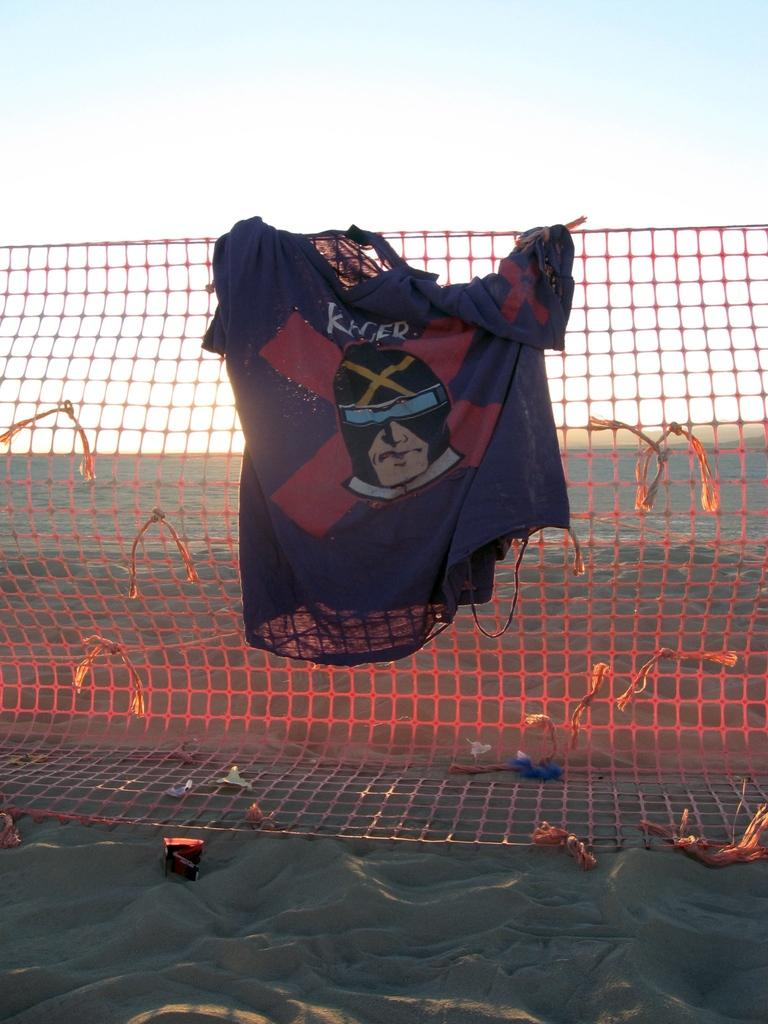What color is the cloth in the image? The cloth in the image is black. What is the black cloth placed on? The black cloth is on an orange net. What can be seen in the image besides the black cloth and orange net? There are objects visible in the image. What type of terrain is present in the image? There is sand in the image. What colors are visible in the sky in the image? The sky is white and blue in color. What type of teeth can be seen in the image? There are no teeth visible in the image. What is the eggnog being used for in the image? There is no eggnog present in the image. 